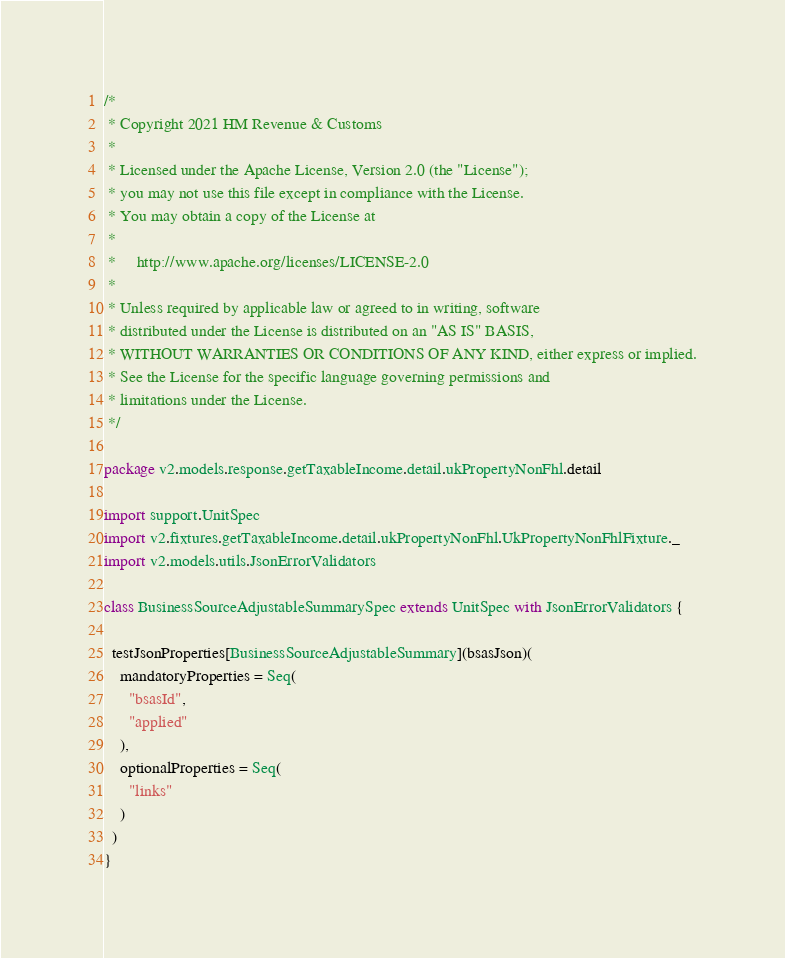<code> <loc_0><loc_0><loc_500><loc_500><_Scala_>/*
 * Copyright 2021 HM Revenue & Customs
 *
 * Licensed under the Apache License, Version 2.0 (the "License");
 * you may not use this file except in compliance with the License.
 * You may obtain a copy of the License at
 *
 *     http://www.apache.org/licenses/LICENSE-2.0
 *
 * Unless required by applicable law or agreed to in writing, software
 * distributed under the License is distributed on an "AS IS" BASIS,
 * WITHOUT WARRANTIES OR CONDITIONS OF ANY KIND, either express or implied.
 * See the License for the specific language governing permissions and
 * limitations under the License.
 */

package v2.models.response.getTaxableIncome.detail.ukPropertyNonFhl.detail

import support.UnitSpec
import v2.fixtures.getTaxableIncome.detail.ukPropertyNonFhl.UkPropertyNonFhlFixture._
import v2.models.utils.JsonErrorValidators

class BusinessSourceAdjustableSummarySpec extends UnitSpec with JsonErrorValidators {

  testJsonProperties[BusinessSourceAdjustableSummary](bsasJson)(
    mandatoryProperties = Seq(
      "bsasId",
      "applied"
    ),
    optionalProperties = Seq(
      "links"
    )
  )
}</code> 